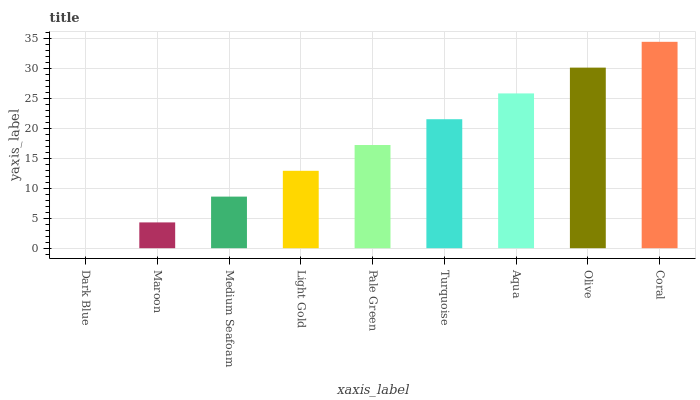Is Dark Blue the minimum?
Answer yes or no. Yes. Is Coral the maximum?
Answer yes or no. Yes. Is Maroon the minimum?
Answer yes or no. No. Is Maroon the maximum?
Answer yes or no. No. Is Maroon greater than Dark Blue?
Answer yes or no. Yes. Is Dark Blue less than Maroon?
Answer yes or no. Yes. Is Dark Blue greater than Maroon?
Answer yes or no. No. Is Maroon less than Dark Blue?
Answer yes or no. No. Is Pale Green the high median?
Answer yes or no. Yes. Is Pale Green the low median?
Answer yes or no. Yes. Is Coral the high median?
Answer yes or no. No. Is Maroon the low median?
Answer yes or no. No. 